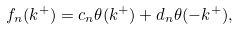Convert formula to latex. <formula><loc_0><loc_0><loc_500><loc_500>f _ { n } ( k ^ { + } ) = c _ { n } \theta ( k ^ { + } ) + d _ { n } \theta ( - k ^ { + } ) ,</formula> 